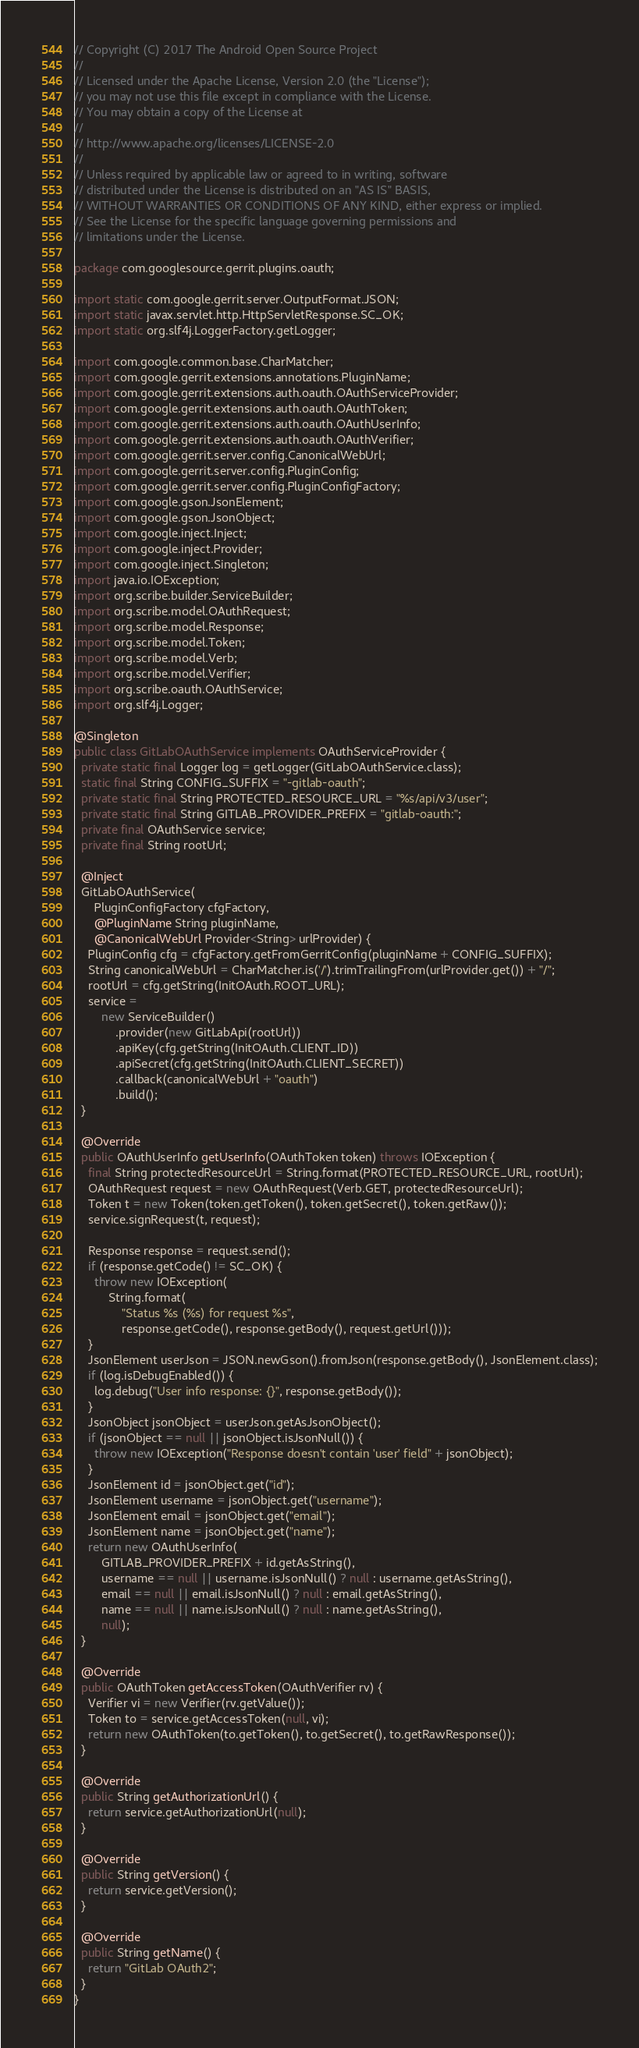<code> <loc_0><loc_0><loc_500><loc_500><_Java_>// Copyright (C) 2017 The Android Open Source Project
//
// Licensed under the Apache License, Version 2.0 (the "License");
// you may not use this file except in compliance with the License.
// You may obtain a copy of the License at
//
// http://www.apache.org/licenses/LICENSE-2.0
//
// Unless required by applicable law or agreed to in writing, software
// distributed under the License is distributed on an "AS IS" BASIS,
// WITHOUT WARRANTIES OR CONDITIONS OF ANY KIND, either express or implied.
// See the License for the specific language governing permissions and
// limitations under the License.

package com.googlesource.gerrit.plugins.oauth;

import static com.google.gerrit.server.OutputFormat.JSON;
import static javax.servlet.http.HttpServletResponse.SC_OK;
import static org.slf4j.LoggerFactory.getLogger;

import com.google.common.base.CharMatcher;
import com.google.gerrit.extensions.annotations.PluginName;
import com.google.gerrit.extensions.auth.oauth.OAuthServiceProvider;
import com.google.gerrit.extensions.auth.oauth.OAuthToken;
import com.google.gerrit.extensions.auth.oauth.OAuthUserInfo;
import com.google.gerrit.extensions.auth.oauth.OAuthVerifier;
import com.google.gerrit.server.config.CanonicalWebUrl;
import com.google.gerrit.server.config.PluginConfig;
import com.google.gerrit.server.config.PluginConfigFactory;
import com.google.gson.JsonElement;
import com.google.gson.JsonObject;
import com.google.inject.Inject;
import com.google.inject.Provider;
import com.google.inject.Singleton;
import java.io.IOException;
import org.scribe.builder.ServiceBuilder;
import org.scribe.model.OAuthRequest;
import org.scribe.model.Response;
import org.scribe.model.Token;
import org.scribe.model.Verb;
import org.scribe.model.Verifier;
import org.scribe.oauth.OAuthService;
import org.slf4j.Logger;

@Singleton
public class GitLabOAuthService implements OAuthServiceProvider {
  private static final Logger log = getLogger(GitLabOAuthService.class);
  static final String CONFIG_SUFFIX = "-gitlab-oauth";
  private static final String PROTECTED_RESOURCE_URL = "%s/api/v3/user";
  private static final String GITLAB_PROVIDER_PREFIX = "gitlab-oauth:";
  private final OAuthService service;
  private final String rootUrl;

  @Inject
  GitLabOAuthService(
      PluginConfigFactory cfgFactory,
      @PluginName String pluginName,
      @CanonicalWebUrl Provider<String> urlProvider) {
    PluginConfig cfg = cfgFactory.getFromGerritConfig(pluginName + CONFIG_SUFFIX);
    String canonicalWebUrl = CharMatcher.is('/').trimTrailingFrom(urlProvider.get()) + "/";
    rootUrl = cfg.getString(InitOAuth.ROOT_URL);
    service =
        new ServiceBuilder()
            .provider(new GitLabApi(rootUrl))
            .apiKey(cfg.getString(InitOAuth.CLIENT_ID))
            .apiSecret(cfg.getString(InitOAuth.CLIENT_SECRET))
            .callback(canonicalWebUrl + "oauth")
            .build();
  }

  @Override
  public OAuthUserInfo getUserInfo(OAuthToken token) throws IOException {
    final String protectedResourceUrl = String.format(PROTECTED_RESOURCE_URL, rootUrl);
    OAuthRequest request = new OAuthRequest(Verb.GET, protectedResourceUrl);
    Token t = new Token(token.getToken(), token.getSecret(), token.getRaw());
    service.signRequest(t, request);

    Response response = request.send();
    if (response.getCode() != SC_OK) {
      throw new IOException(
          String.format(
              "Status %s (%s) for request %s",
              response.getCode(), response.getBody(), request.getUrl()));
    }
    JsonElement userJson = JSON.newGson().fromJson(response.getBody(), JsonElement.class);
    if (log.isDebugEnabled()) {
      log.debug("User info response: {}", response.getBody());
    }
    JsonObject jsonObject = userJson.getAsJsonObject();
    if (jsonObject == null || jsonObject.isJsonNull()) {
      throw new IOException("Response doesn't contain 'user' field" + jsonObject);
    }
    JsonElement id = jsonObject.get("id");
    JsonElement username = jsonObject.get("username");
    JsonElement email = jsonObject.get("email");
    JsonElement name = jsonObject.get("name");
    return new OAuthUserInfo(
        GITLAB_PROVIDER_PREFIX + id.getAsString(),
        username == null || username.isJsonNull() ? null : username.getAsString(),
        email == null || email.isJsonNull() ? null : email.getAsString(),
        name == null || name.isJsonNull() ? null : name.getAsString(),
        null);
  }

  @Override
  public OAuthToken getAccessToken(OAuthVerifier rv) {
    Verifier vi = new Verifier(rv.getValue());
    Token to = service.getAccessToken(null, vi);
    return new OAuthToken(to.getToken(), to.getSecret(), to.getRawResponse());
  }

  @Override
  public String getAuthorizationUrl() {
    return service.getAuthorizationUrl(null);
  }

  @Override
  public String getVersion() {
    return service.getVersion();
  }

  @Override
  public String getName() {
    return "GitLab OAuth2";
  }
}
</code> 